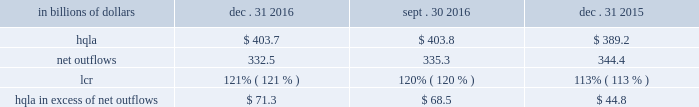Liquidity monitoring and measurement stress testing liquidity stress testing is performed for each of citi 2019s major entities , operating subsidiaries and/or countries .
Stress testing and scenario analyses are intended to quantify the potential impact of a liquidity event on the balance sheet and liquidity position , and to identify viable funding alternatives that can be utilized .
These scenarios include assumptions about significant changes in key funding sources , market triggers ( such as credit ratings ) , potential uses of funding and political and economic conditions in certain countries .
These conditions include expected and stressed market conditions as well as company- specific events .
Liquidity stress tests are conducted to ascertain potential mismatches between liquidity sources and uses over a variety of time horizons ( overnight , one week , two weeks , one month , three months , one year ) and over a variety of stressed conditions .
Liquidity limits are set accordingly .
To monitor the liquidity of an entity , these stress tests and potential mismatches are calculated with varying frequencies , with several tests performed daily .
Given the range of potential stresses , citi maintains a series of contingency funding plans on a consolidated basis and for individual entities .
These plans specify a wide range of readily available actions for a variety of adverse market conditions or idiosyncratic stresses .
Short-term liquidity measurement : liquidity coverage ratio ( lcr ) in addition to internal measures that citi has developed for a 30-day stress scenario , citi also monitors its liquidity by reference to the lcr , as calculated pursuant to the u.s .
Lcr rules .
Generally , the lcr is designed to ensure that banks maintain an adequate level of hqla to meet liquidity needs under an acute 30-day stress scenario .
The lcr is calculated by dividing hqla by estimated net outflows over a stressed 30-day period , with the net outflows determined by applying prescribed outflow factors to various categories of liabilities , such as deposits , unsecured and secured wholesale borrowings , unused lending commitments and derivatives- related exposures , partially offset by inflows from assets maturing within 30 days .
Banks are required to calculate an add-on to address potential maturity mismatches between contractual cash outflows and inflows within the 30-day period in determining the total amount of net outflows .
The minimum lcr requirement is 100% ( 100 % ) , effective january 2017 .
In december 2016 , the federal reserve board adopted final rules which require additional disclosures relating to the lcr of large financial institutions , including citi .
Among other things , the final rules require citi to disclose components of its average hqla , lcr and inflows and outflows each quarter .
In addition , the final rules require disclosure of citi 2019s calculation of the maturity mismatch add-on as well as other qualitative disclosures .
The effective date for these disclosures is april 1 , 2017 .
The table below sets forth the components of citi 2019s lcr calculation and hqla in excess of net outflows for the periods indicated : in billions of dollars dec .
31 , sept .
30 , dec .
31 .
Note : amounts set forth in the table above are presented on an average basis .
As set forth in the table above , citi 2019s lcr increased both year-over-year and sequentially .
The increase year-over-year was driven by both an increase in hqla and a reduction in net outflows .
Sequentially , the increase was driven by a slight reduction in net outflows , as hqla remained largely unchanged .
Long-term liquidity measurement : net stable funding ratio ( nsfr ) in the second quarter of 2016 , the federal reserve board , the fdic and the occ issued a proposed rule to implement the basel iii nsfr requirement .
The u.s.-proposed nsfr is largely consistent with the basel committee 2019s final nsfr rules .
In general , the nsfr assesses the availability of a bank 2019s stable funding against a required level .
A bank 2019s available stable funding would include portions of equity , deposits and long-term debt , while its required stable funding would be based on the liquidity characteristics of its assets , derivatives and commitments .
Standardized weightings would be required to be applied to the various asset and liabilities classes .
The ratio of available stable funding to required stable funding would be required to be greater than 100% ( 100 % ) .
While citi believes that it is compliant with the proposed u.s .
Nsfr rules as of december 31 , 2016 , it will need to evaluate any final version of the rules , which are expected to be released during 2017 .
The proposed rules would require full implementation of the u.s .
Nsfr beginning january 1 , 2018. .
What was the percentage increase in the liquidity coverage ratio ( lcr ) for citi from 2015 to 2016? 
Computations: ((121 - 113) / 113)
Answer: 0.0708. Liquidity monitoring and measurement stress testing liquidity stress testing is performed for each of citi 2019s major entities , operating subsidiaries and/or countries .
Stress testing and scenario analyses are intended to quantify the potential impact of a liquidity event on the balance sheet and liquidity position , and to identify viable funding alternatives that can be utilized .
These scenarios include assumptions about significant changes in key funding sources , market triggers ( such as credit ratings ) , potential uses of funding and political and economic conditions in certain countries .
These conditions include expected and stressed market conditions as well as company- specific events .
Liquidity stress tests are conducted to ascertain potential mismatches between liquidity sources and uses over a variety of time horizons ( overnight , one week , two weeks , one month , three months , one year ) and over a variety of stressed conditions .
Liquidity limits are set accordingly .
To monitor the liquidity of an entity , these stress tests and potential mismatches are calculated with varying frequencies , with several tests performed daily .
Given the range of potential stresses , citi maintains a series of contingency funding plans on a consolidated basis and for individual entities .
These plans specify a wide range of readily available actions for a variety of adverse market conditions or idiosyncratic stresses .
Short-term liquidity measurement : liquidity coverage ratio ( lcr ) in addition to internal measures that citi has developed for a 30-day stress scenario , citi also monitors its liquidity by reference to the lcr , as calculated pursuant to the u.s .
Lcr rules .
Generally , the lcr is designed to ensure that banks maintain an adequate level of hqla to meet liquidity needs under an acute 30-day stress scenario .
The lcr is calculated by dividing hqla by estimated net outflows over a stressed 30-day period , with the net outflows determined by applying prescribed outflow factors to various categories of liabilities , such as deposits , unsecured and secured wholesale borrowings , unused lending commitments and derivatives- related exposures , partially offset by inflows from assets maturing within 30 days .
Banks are required to calculate an add-on to address potential maturity mismatches between contractual cash outflows and inflows within the 30-day period in determining the total amount of net outflows .
The minimum lcr requirement is 100% ( 100 % ) , effective january 2017 .
In december 2016 , the federal reserve board adopted final rules which require additional disclosures relating to the lcr of large financial institutions , including citi .
Among other things , the final rules require citi to disclose components of its average hqla , lcr and inflows and outflows each quarter .
In addition , the final rules require disclosure of citi 2019s calculation of the maturity mismatch add-on as well as other qualitative disclosures .
The effective date for these disclosures is april 1 , 2017 .
The table below sets forth the components of citi 2019s lcr calculation and hqla in excess of net outflows for the periods indicated : in billions of dollars dec .
31 , sept .
30 , dec .
31 .
Note : amounts set forth in the table above are presented on an average basis .
As set forth in the table above , citi 2019s lcr increased both year-over-year and sequentially .
The increase year-over-year was driven by both an increase in hqla and a reduction in net outflows .
Sequentially , the increase was driven by a slight reduction in net outflows , as hqla remained largely unchanged .
Long-term liquidity measurement : net stable funding ratio ( nsfr ) in the second quarter of 2016 , the federal reserve board , the fdic and the occ issued a proposed rule to implement the basel iii nsfr requirement .
The u.s.-proposed nsfr is largely consistent with the basel committee 2019s final nsfr rules .
In general , the nsfr assesses the availability of a bank 2019s stable funding against a required level .
A bank 2019s available stable funding would include portions of equity , deposits and long-term debt , while its required stable funding would be based on the liquidity characteristics of its assets , derivatives and commitments .
Standardized weightings would be required to be applied to the various asset and liabilities classes .
The ratio of available stable funding to required stable funding would be required to be greater than 100% ( 100 % ) .
While citi believes that it is compliant with the proposed u.s .
Nsfr rules as of december 31 , 2016 , it will need to evaluate any final version of the rules , which are expected to be released during 2017 .
The proposed rules would require full implementation of the u.s .
Nsfr beginning january 1 , 2018. .
What was the change in billions of net outflows from december 31 , 2015 to december 31 , 2016? 
Computations: (332.5 - 344.4)
Answer: -11.9. Liquidity monitoring and measurement stress testing liquidity stress testing is performed for each of citi 2019s major entities , operating subsidiaries and/or countries .
Stress testing and scenario analyses are intended to quantify the potential impact of a liquidity event on the balance sheet and liquidity position , and to identify viable funding alternatives that can be utilized .
These scenarios include assumptions about significant changes in key funding sources , market triggers ( such as credit ratings ) , potential uses of funding and political and economic conditions in certain countries .
These conditions include expected and stressed market conditions as well as company- specific events .
Liquidity stress tests are conducted to ascertain potential mismatches between liquidity sources and uses over a variety of time horizons ( overnight , one week , two weeks , one month , three months , one year ) and over a variety of stressed conditions .
Liquidity limits are set accordingly .
To monitor the liquidity of an entity , these stress tests and potential mismatches are calculated with varying frequencies , with several tests performed daily .
Given the range of potential stresses , citi maintains a series of contingency funding plans on a consolidated basis and for individual entities .
These plans specify a wide range of readily available actions for a variety of adverse market conditions or idiosyncratic stresses .
Short-term liquidity measurement : liquidity coverage ratio ( lcr ) in addition to internal measures that citi has developed for a 30-day stress scenario , citi also monitors its liquidity by reference to the lcr , as calculated pursuant to the u.s .
Lcr rules .
Generally , the lcr is designed to ensure that banks maintain an adequate level of hqla to meet liquidity needs under an acute 30-day stress scenario .
The lcr is calculated by dividing hqla by estimated net outflows over a stressed 30-day period , with the net outflows determined by applying prescribed outflow factors to various categories of liabilities , such as deposits , unsecured and secured wholesale borrowings , unused lending commitments and derivatives- related exposures , partially offset by inflows from assets maturing within 30 days .
Banks are required to calculate an add-on to address potential maturity mismatches between contractual cash outflows and inflows within the 30-day period in determining the total amount of net outflows .
The minimum lcr requirement is 100% ( 100 % ) , effective january 2017 .
In december 2016 , the federal reserve board adopted final rules which require additional disclosures relating to the lcr of large financial institutions , including citi .
Among other things , the final rules require citi to disclose components of its average hqla , lcr and inflows and outflows each quarter .
In addition , the final rules require disclosure of citi 2019s calculation of the maturity mismatch add-on as well as other qualitative disclosures .
The effective date for these disclosures is april 1 , 2017 .
The table below sets forth the components of citi 2019s lcr calculation and hqla in excess of net outflows for the periods indicated : in billions of dollars dec .
31 , sept .
30 , dec .
31 .
Note : amounts set forth in the table above are presented on an average basis .
As set forth in the table above , citi 2019s lcr increased both year-over-year and sequentially .
The increase year-over-year was driven by both an increase in hqla and a reduction in net outflows .
Sequentially , the increase was driven by a slight reduction in net outflows , as hqla remained largely unchanged .
Long-term liquidity measurement : net stable funding ratio ( nsfr ) in the second quarter of 2016 , the federal reserve board , the fdic and the occ issued a proposed rule to implement the basel iii nsfr requirement .
The u.s.-proposed nsfr is largely consistent with the basel committee 2019s final nsfr rules .
In general , the nsfr assesses the availability of a bank 2019s stable funding against a required level .
A bank 2019s available stable funding would include portions of equity , deposits and long-term debt , while its required stable funding would be based on the liquidity characteristics of its assets , derivatives and commitments .
Standardized weightings would be required to be applied to the various asset and liabilities classes .
The ratio of available stable funding to required stable funding would be required to be greater than 100% ( 100 % ) .
While citi believes that it is compliant with the proposed u.s .
Nsfr rules as of december 31 , 2016 , it will need to evaluate any final version of the rules , which are expected to be released during 2017 .
The proposed rules would require full implementation of the u.s .
Nsfr beginning january 1 , 2018. .
What was the percent of the increase in the high quality liquid assets ( hqla ) for citi from 2015 to 2016? 
Computations: (403.7 - 389.2)
Answer: 14.5. 